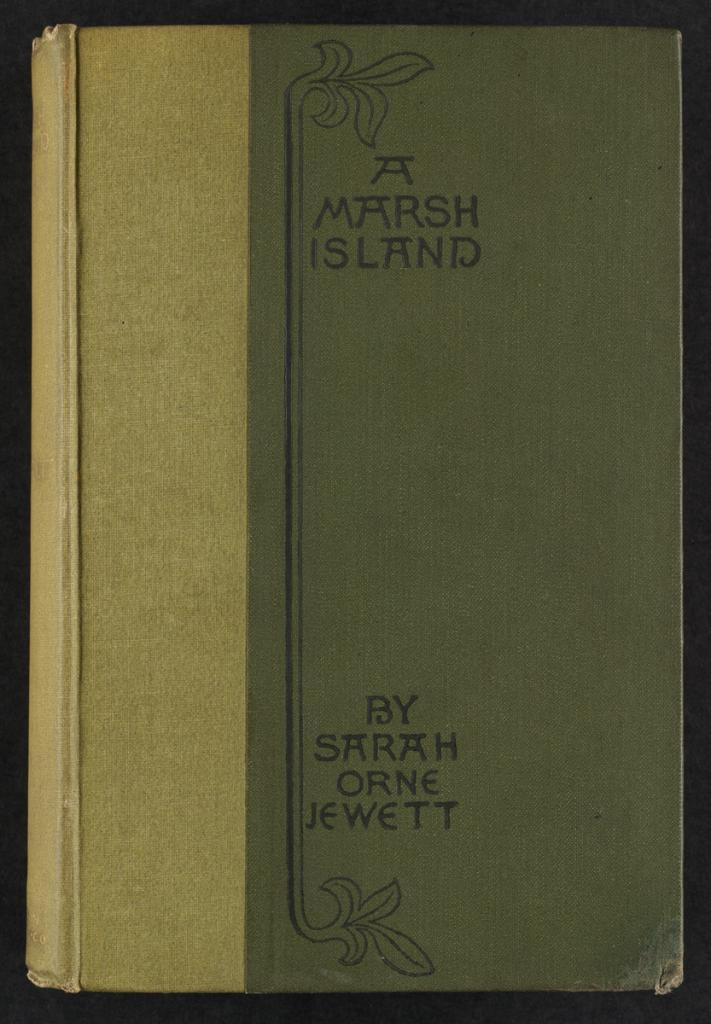<image>
Share a concise interpretation of the image provided. The author of this old book is called Sarsh Orne Jewett. 